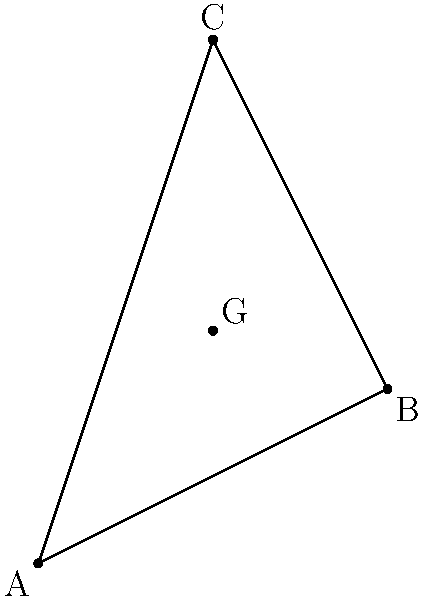Given a triangle with vertices A(1,1), B(5,3), and C(3,7), determine the exact coordinates of the centroid G. Provide your answer as an ordered pair (x,y) with fractions in their simplest form. To find the coordinates of the centroid of a triangle, we follow these steps:

1) The centroid formula states that the coordinates of the centroid G(x,y) are:

   $$x = \frac{x_A + x_B + x_C}{3}$$ and $$y = \frac{y_A + y_B + y_C}{3}$$

   where (x_A, y_A), (x_B, y_B), and (x_C, y_C) are the coordinates of the triangle's vertices.

2) Let's substitute the given coordinates:
   A(1,1), B(5,3), C(3,7)

3) For the x-coordinate of the centroid:
   $$x = \frac{1 + 5 + 3}{3} = \frac{9}{3} = 3$$

4) For the y-coordinate of the centroid:
   $$y = \frac{1 + 3 + 7}{3} = \frac{11}{3}$$

5) The fraction $\frac{11}{3}$ is already in its simplest form.

Therefore, the coordinates of the centroid G are (3, $\frac{11}{3}$).
Answer: $(3, \frac{11}{3})$ 